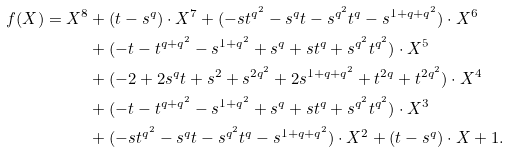<formula> <loc_0><loc_0><loc_500><loc_500>f ( X ) = X ^ { 8 } & + ( t - s ^ { q } ) \cdot X ^ { 7 } + ( - s t ^ { q ^ { 2 } } - s ^ { q } t - s ^ { q ^ { 2 } } t ^ { q } - s ^ { 1 + q + q ^ { 2 } } ) \cdot X ^ { 6 } \\ & + ( - t - t ^ { q + q ^ { 2 } } - s ^ { 1 + q ^ { 2 } } + s ^ { q } + s t ^ { q } + s ^ { q ^ { 2 } } t ^ { q ^ { 2 } } ) \cdot X ^ { 5 } \\ & + ( - 2 + 2 s ^ { q } t + s ^ { 2 } + s ^ { 2 q ^ { 2 } } + 2 s ^ { 1 + q + q ^ { 2 } } + t ^ { 2 q } + t ^ { 2 q ^ { 2 } } ) \cdot X ^ { 4 } \\ & + ( - t - t ^ { q + q ^ { 2 } } - s ^ { 1 + q ^ { 2 } } + s ^ { q } + s t ^ { q } + s ^ { q ^ { 2 } } t ^ { q ^ { 2 } } ) \cdot X ^ { 3 } \\ & + ( - s t ^ { q ^ { 2 } } - s ^ { q } t - s ^ { q ^ { 2 } } t ^ { q } - s ^ { 1 + q + q ^ { 2 } } ) \cdot X ^ { 2 } + ( t - s ^ { q } ) \cdot X + 1 .</formula> 